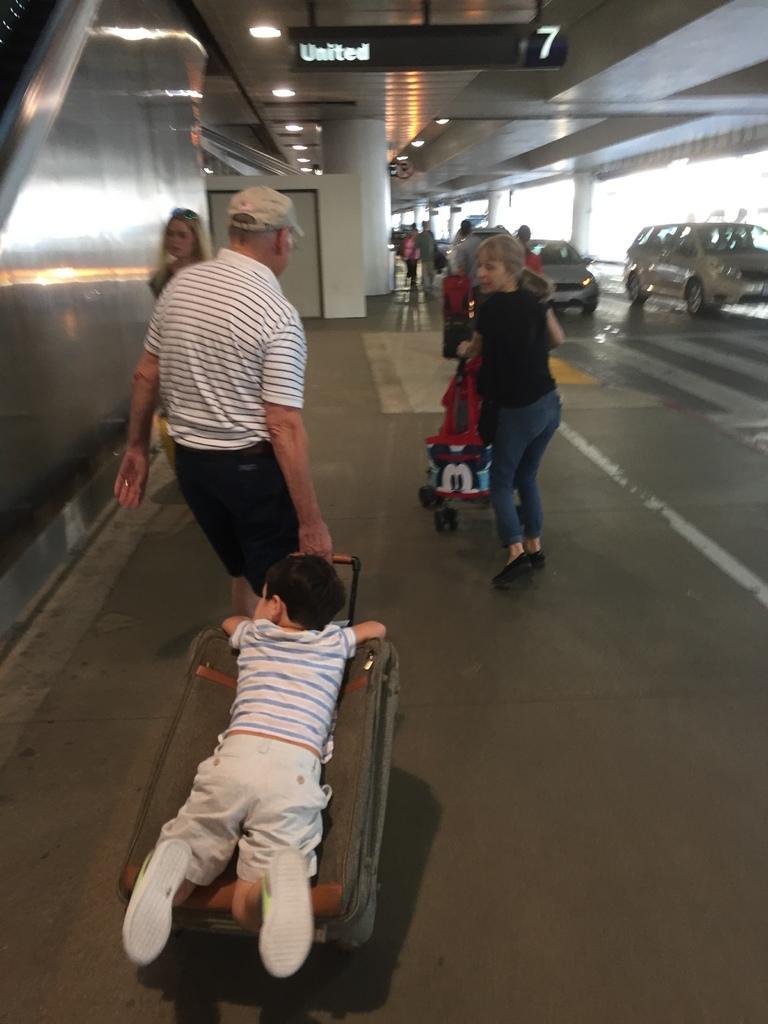In one or two sentences, can you explain what this image depicts? In this image I can see there are few persons walking and they are holding trolleys, there is a boy lying on the trolley and there are few cars at right side, there are a few pillars to the right. 